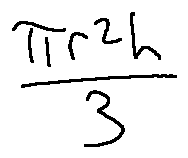Convert formula to latex. <formula><loc_0><loc_0><loc_500><loc_500>\frac { \pi r ^ { 2 } h } { 3 }</formula> 